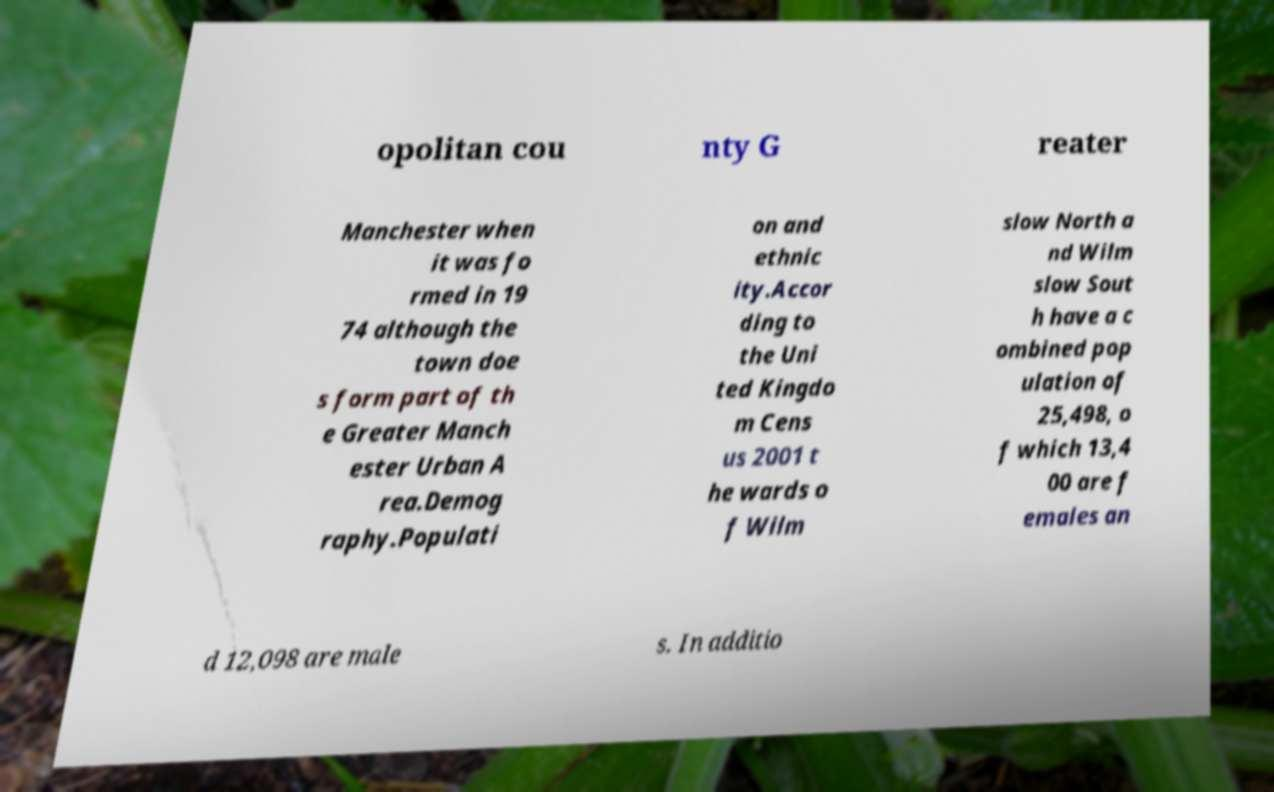Can you read and provide the text displayed in the image?This photo seems to have some interesting text. Can you extract and type it out for me? opolitan cou nty G reater Manchester when it was fo rmed in 19 74 although the town doe s form part of th e Greater Manch ester Urban A rea.Demog raphy.Populati on and ethnic ity.Accor ding to the Uni ted Kingdo m Cens us 2001 t he wards o f Wilm slow North a nd Wilm slow Sout h have a c ombined pop ulation of 25,498, o f which 13,4 00 are f emales an d 12,098 are male s. In additio 